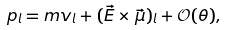<formula> <loc_0><loc_0><loc_500><loc_500>p _ { l } = m v _ { l } + ( \vec { E } \times \vec { \mu } ) _ { l } + \mathcal { O } ( \theta ) ,</formula> 